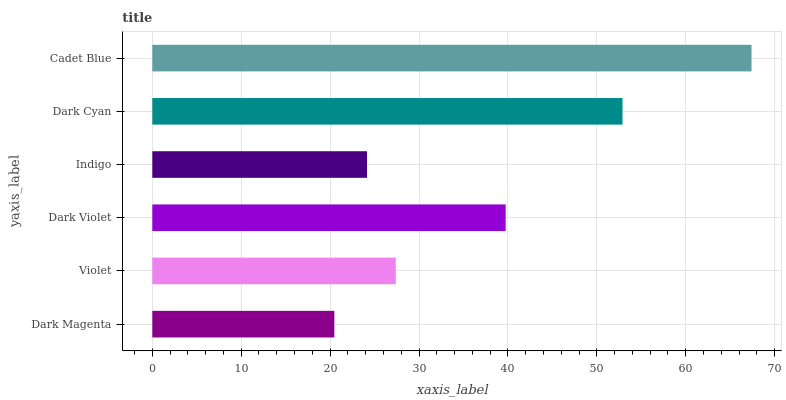Is Dark Magenta the minimum?
Answer yes or no. Yes. Is Cadet Blue the maximum?
Answer yes or no. Yes. Is Violet the minimum?
Answer yes or no. No. Is Violet the maximum?
Answer yes or no. No. Is Violet greater than Dark Magenta?
Answer yes or no. Yes. Is Dark Magenta less than Violet?
Answer yes or no. Yes. Is Dark Magenta greater than Violet?
Answer yes or no. No. Is Violet less than Dark Magenta?
Answer yes or no. No. Is Dark Violet the high median?
Answer yes or no. Yes. Is Violet the low median?
Answer yes or no. Yes. Is Violet the high median?
Answer yes or no. No. Is Dark Magenta the low median?
Answer yes or no. No. 